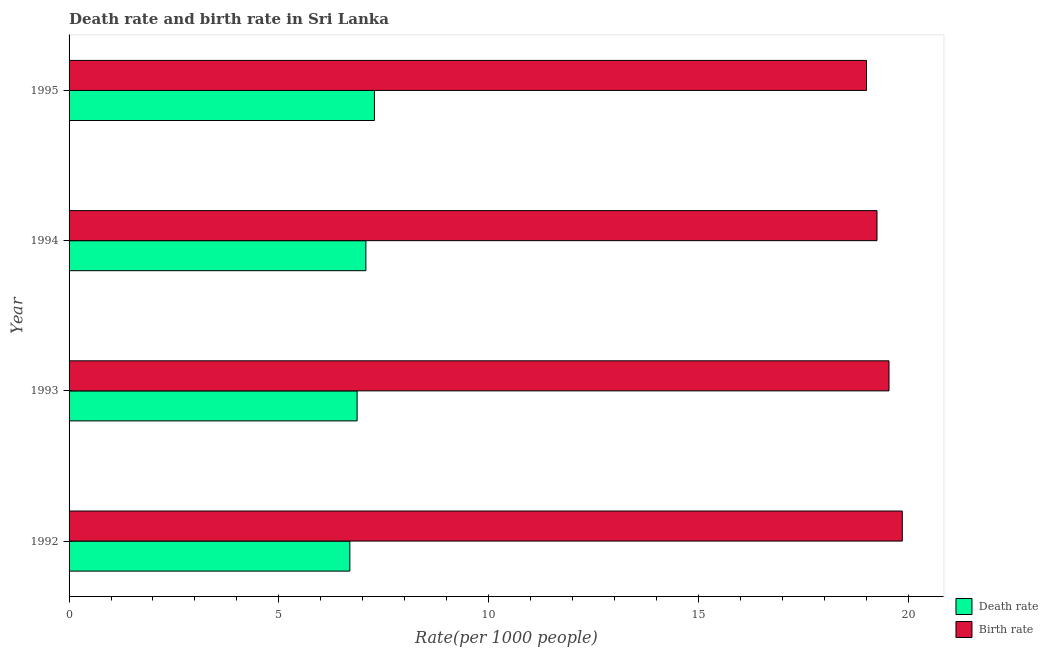How many different coloured bars are there?
Your response must be concise. 2. How many groups of bars are there?
Keep it short and to the point. 4. Are the number of bars per tick equal to the number of legend labels?
Provide a short and direct response. Yes. Are the number of bars on each tick of the Y-axis equal?
Your response must be concise. Yes. How many bars are there on the 3rd tick from the top?
Your response must be concise. 2. How many bars are there on the 4th tick from the bottom?
Your answer should be very brief. 2. What is the death rate in 1993?
Provide a short and direct response. 6.87. Across all years, what is the maximum death rate?
Your response must be concise. 7.28. Across all years, what is the minimum death rate?
Offer a very short reply. 6.69. In which year was the death rate maximum?
Provide a succinct answer. 1995. What is the total birth rate in the graph?
Offer a very short reply. 77.67. What is the difference between the death rate in 1994 and that in 1995?
Make the answer very short. -0.2. What is the difference between the birth rate in 1995 and the death rate in 1994?
Your answer should be compact. 11.93. What is the average death rate per year?
Ensure brevity in your answer.  6.98. In the year 1992, what is the difference between the birth rate and death rate?
Make the answer very short. 13.17. In how many years, is the death rate greater than 9 ?
Offer a very short reply. 0. What is the ratio of the death rate in 1992 to that in 1994?
Ensure brevity in your answer.  0.95. Is the birth rate in 1993 less than that in 1994?
Your answer should be compact. No. Is the difference between the death rate in 1992 and 1993 greater than the difference between the birth rate in 1992 and 1993?
Ensure brevity in your answer.  No. What is the difference between the highest and the second highest birth rate?
Offer a very short reply. 0.32. What is the difference between the highest and the lowest death rate?
Offer a terse response. 0.59. Is the sum of the birth rate in 1992 and 1995 greater than the maximum death rate across all years?
Your response must be concise. Yes. What does the 1st bar from the top in 1993 represents?
Ensure brevity in your answer.  Birth rate. What does the 1st bar from the bottom in 1993 represents?
Your answer should be compact. Death rate. How many bars are there?
Provide a succinct answer. 8. Are all the bars in the graph horizontal?
Your answer should be compact. Yes. How many years are there in the graph?
Your response must be concise. 4. Are the values on the major ticks of X-axis written in scientific E-notation?
Keep it short and to the point. No. Does the graph contain any zero values?
Provide a short and direct response. No. Does the graph contain grids?
Make the answer very short. No. Where does the legend appear in the graph?
Keep it short and to the point. Bottom right. How are the legend labels stacked?
Provide a succinct answer. Vertical. What is the title of the graph?
Your answer should be compact. Death rate and birth rate in Sri Lanka. What is the label or title of the X-axis?
Ensure brevity in your answer.  Rate(per 1000 people). What is the label or title of the Y-axis?
Your response must be concise. Year. What is the Rate(per 1000 people) of Death rate in 1992?
Offer a very short reply. 6.69. What is the Rate(per 1000 people) of Birth rate in 1992?
Provide a short and direct response. 19.86. What is the Rate(per 1000 people) of Death rate in 1993?
Your response must be concise. 6.87. What is the Rate(per 1000 people) of Birth rate in 1993?
Ensure brevity in your answer.  19.55. What is the Rate(per 1000 people) in Death rate in 1994?
Your response must be concise. 7.08. What is the Rate(per 1000 people) of Birth rate in 1994?
Make the answer very short. 19.26. What is the Rate(per 1000 people) of Death rate in 1995?
Provide a succinct answer. 7.28. What is the Rate(per 1000 people) in Birth rate in 1995?
Ensure brevity in your answer.  19.01. Across all years, what is the maximum Rate(per 1000 people) of Death rate?
Your answer should be very brief. 7.28. Across all years, what is the maximum Rate(per 1000 people) in Birth rate?
Provide a succinct answer. 19.86. Across all years, what is the minimum Rate(per 1000 people) in Death rate?
Your answer should be very brief. 6.69. Across all years, what is the minimum Rate(per 1000 people) in Birth rate?
Provide a short and direct response. 19.01. What is the total Rate(per 1000 people) in Death rate in the graph?
Your answer should be very brief. 27.91. What is the total Rate(per 1000 people) in Birth rate in the graph?
Your answer should be very brief. 77.67. What is the difference between the Rate(per 1000 people) of Death rate in 1992 and that in 1993?
Provide a succinct answer. -0.17. What is the difference between the Rate(per 1000 people) of Birth rate in 1992 and that in 1993?
Your response must be concise. 0.32. What is the difference between the Rate(per 1000 people) in Death rate in 1992 and that in 1994?
Offer a terse response. -0.38. What is the difference between the Rate(per 1000 people) in Birth rate in 1992 and that in 1994?
Provide a short and direct response. 0.6. What is the difference between the Rate(per 1000 people) of Death rate in 1992 and that in 1995?
Give a very brief answer. -0.59. What is the difference between the Rate(per 1000 people) of Birth rate in 1992 and that in 1995?
Your answer should be compact. 0.85. What is the difference between the Rate(per 1000 people) of Death rate in 1993 and that in 1994?
Ensure brevity in your answer.  -0.21. What is the difference between the Rate(per 1000 people) of Birth rate in 1993 and that in 1994?
Your answer should be very brief. 0.29. What is the difference between the Rate(per 1000 people) in Death rate in 1993 and that in 1995?
Provide a succinct answer. -0.41. What is the difference between the Rate(per 1000 people) of Birth rate in 1993 and that in 1995?
Your answer should be very brief. 0.54. What is the difference between the Rate(per 1000 people) of Death rate in 1994 and that in 1995?
Your response must be concise. -0.2. What is the difference between the Rate(per 1000 people) in Death rate in 1992 and the Rate(per 1000 people) in Birth rate in 1993?
Provide a succinct answer. -12.85. What is the difference between the Rate(per 1000 people) in Death rate in 1992 and the Rate(per 1000 people) in Birth rate in 1994?
Keep it short and to the point. -12.57. What is the difference between the Rate(per 1000 people) of Death rate in 1992 and the Rate(per 1000 people) of Birth rate in 1995?
Make the answer very short. -12.32. What is the difference between the Rate(per 1000 people) in Death rate in 1993 and the Rate(per 1000 people) in Birth rate in 1994?
Make the answer very short. -12.39. What is the difference between the Rate(per 1000 people) in Death rate in 1993 and the Rate(per 1000 people) in Birth rate in 1995?
Your response must be concise. -12.14. What is the difference between the Rate(per 1000 people) of Death rate in 1994 and the Rate(per 1000 people) of Birth rate in 1995?
Provide a short and direct response. -11.93. What is the average Rate(per 1000 people) in Death rate per year?
Offer a very short reply. 6.98. What is the average Rate(per 1000 people) in Birth rate per year?
Keep it short and to the point. 19.42. In the year 1992, what is the difference between the Rate(per 1000 people) in Death rate and Rate(per 1000 people) in Birth rate?
Your answer should be compact. -13.17. In the year 1993, what is the difference between the Rate(per 1000 people) of Death rate and Rate(per 1000 people) of Birth rate?
Offer a terse response. -12.68. In the year 1994, what is the difference between the Rate(per 1000 people) in Death rate and Rate(per 1000 people) in Birth rate?
Your answer should be compact. -12.18. In the year 1995, what is the difference between the Rate(per 1000 people) in Death rate and Rate(per 1000 people) in Birth rate?
Your response must be concise. -11.73. What is the ratio of the Rate(per 1000 people) of Death rate in 1992 to that in 1993?
Your response must be concise. 0.97. What is the ratio of the Rate(per 1000 people) in Birth rate in 1992 to that in 1993?
Keep it short and to the point. 1.02. What is the ratio of the Rate(per 1000 people) of Death rate in 1992 to that in 1994?
Offer a terse response. 0.95. What is the ratio of the Rate(per 1000 people) in Birth rate in 1992 to that in 1994?
Your answer should be compact. 1.03. What is the ratio of the Rate(per 1000 people) of Death rate in 1992 to that in 1995?
Ensure brevity in your answer.  0.92. What is the ratio of the Rate(per 1000 people) of Birth rate in 1992 to that in 1995?
Your answer should be very brief. 1.04. What is the ratio of the Rate(per 1000 people) of Death rate in 1993 to that in 1994?
Provide a succinct answer. 0.97. What is the ratio of the Rate(per 1000 people) in Birth rate in 1993 to that in 1994?
Make the answer very short. 1.01. What is the ratio of the Rate(per 1000 people) of Death rate in 1993 to that in 1995?
Your answer should be very brief. 0.94. What is the ratio of the Rate(per 1000 people) in Birth rate in 1993 to that in 1995?
Provide a succinct answer. 1.03. What is the ratio of the Rate(per 1000 people) in Birth rate in 1994 to that in 1995?
Your answer should be compact. 1.01. What is the difference between the highest and the second highest Rate(per 1000 people) in Death rate?
Provide a short and direct response. 0.2. What is the difference between the highest and the second highest Rate(per 1000 people) in Birth rate?
Offer a terse response. 0.32. What is the difference between the highest and the lowest Rate(per 1000 people) in Death rate?
Your answer should be very brief. 0.59. What is the difference between the highest and the lowest Rate(per 1000 people) of Birth rate?
Provide a succinct answer. 0.85. 